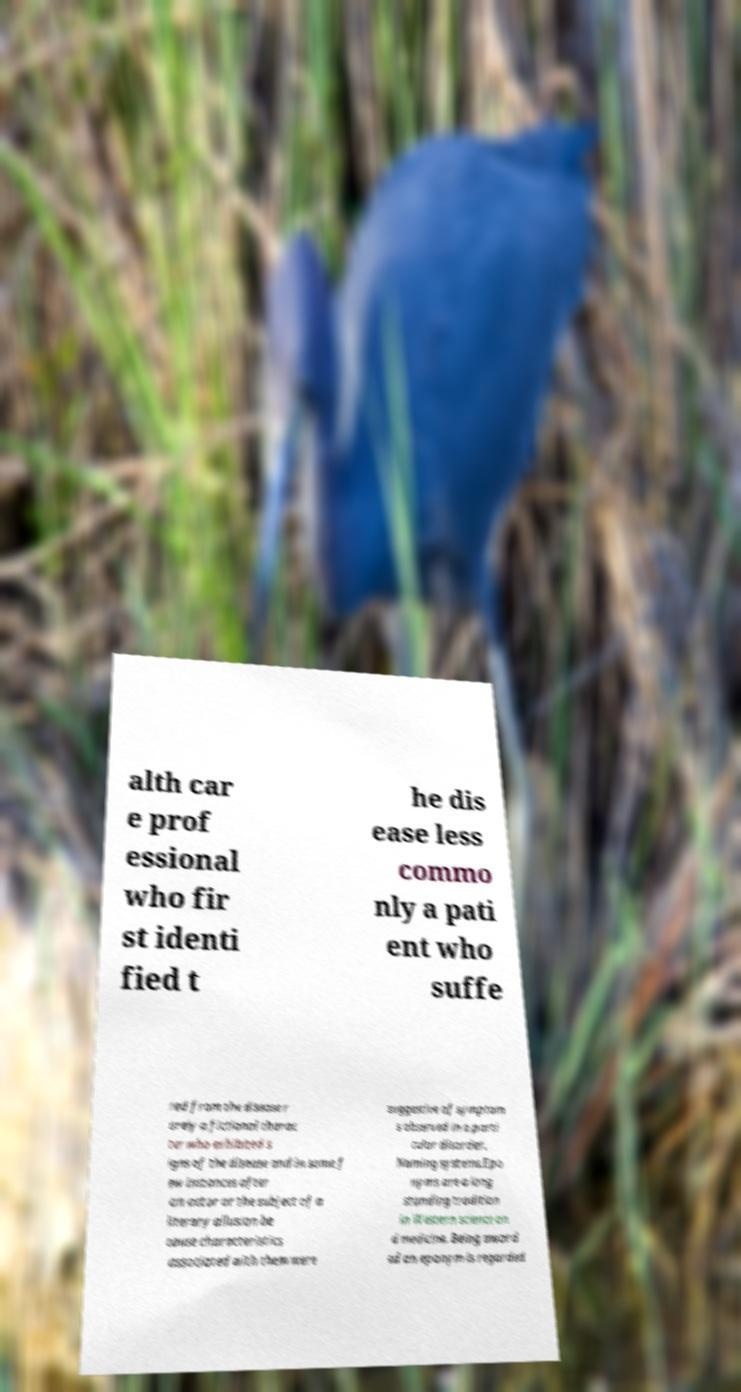For documentation purposes, I need the text within this image transcribed. Could you provide that? alth car e prof essional who fir st identi fied t he dis ease less commo nly a pati ent who suffe red from the disease r arely a fictional charac ter who exhibited s igns of the disease and in some f ew instances after an actor or the subject of a literary allusion be cause characteristics associated with them were suggestive of symptom s observed in a parti cular disorder. Naming systems.Epo nyms are a long standing tradition in Western science an d medicine. Being award ed an eponym is regarded 